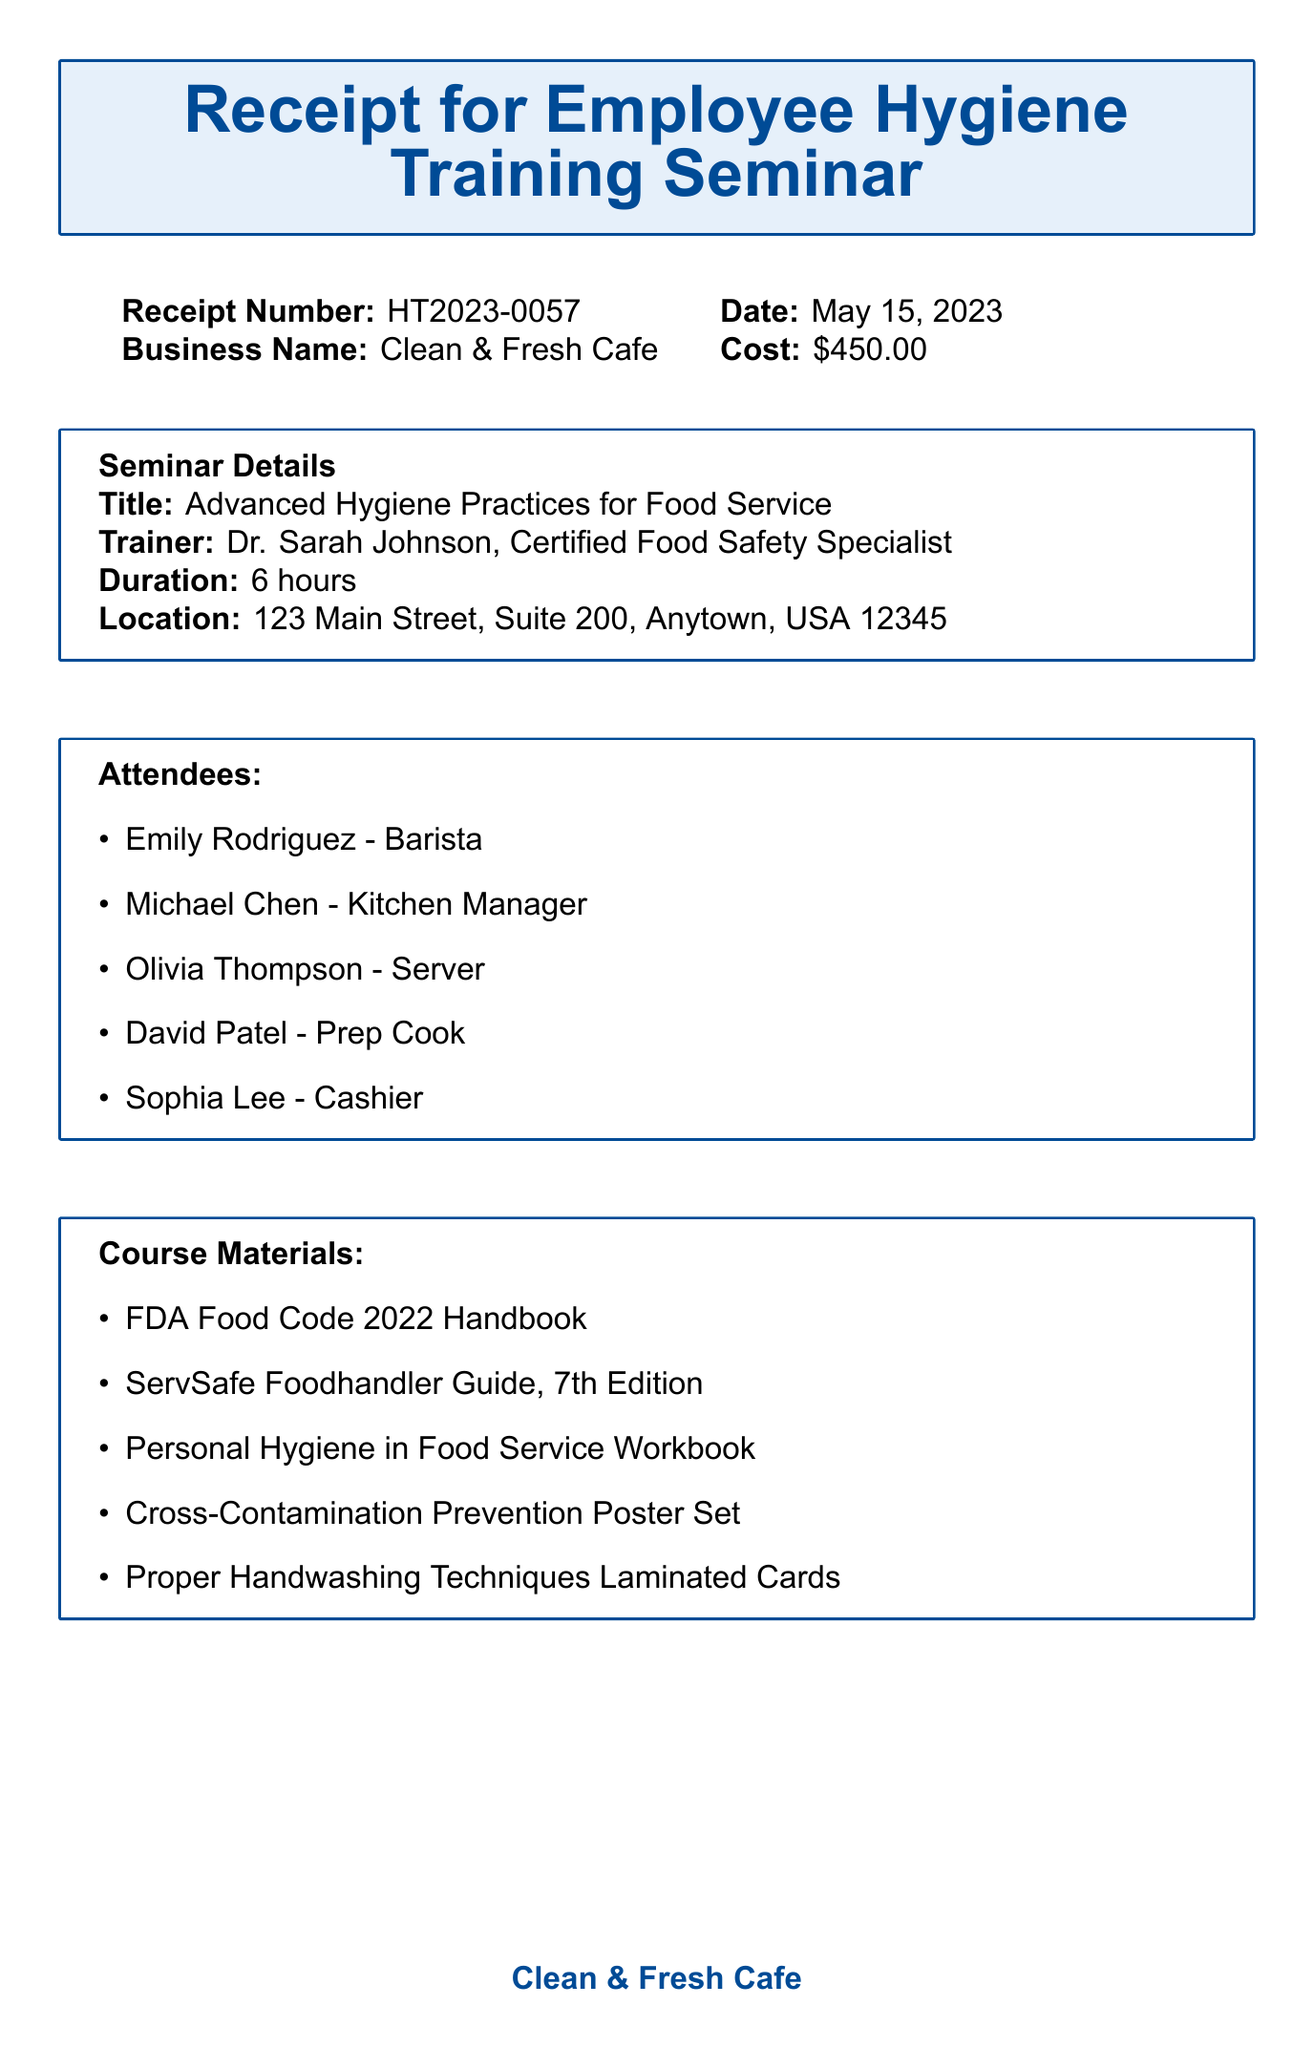What is the receipt number? The receipt number is a specific identifier for the document, which is mentioned in the top section.
Answer: HT2023-0057 Who was the trainer for the seminar? The trainer's name and title are listed in the seminar details section of the document.
Answer: Dr. Sarah Johnson, Certified Food Safety Specialist How many attendees were there at the seminar? The total number of attendees is found by counting the list in the attendees section.
Answer: 5 What is the cost of the seminar? The cost is specified in the document as a fixed amount.
Answer: $450.00 What topics were covered in the seminar? The list of topics in the document outlines what was discussed during the training session.
Answer: Personal hygiene and grooming standards, Proper handwashing techniques and frequency, Foodborne illness prevention, Safe food handling and storage practices, Cleaning and sanitizing procedures for equipment and surfaces, Proper use of personal protective equipment (PPE), Time and temperature control for food safety What additional items were provided during the seminar? The additional items section outlines extra materials given during the training.
Answer: 5 Food Safety Manager Certification Exam Vouchers, 10 Disposable Hair Nets, 2 Digital Probe Thermometers When was the follow-up inspection scheduled? The date for follow-up is mentioned in the notes section, indicating future actions.
Answer: June 1, 2023 How long did the seminar last? The duration of the seminar is explicitly stated in the seminar details section.
Answer: 6 hours What payment method was used? The method of payment is noted in the financial details section of the document.
Answer: Business Credit Card (Visa ****1234) 